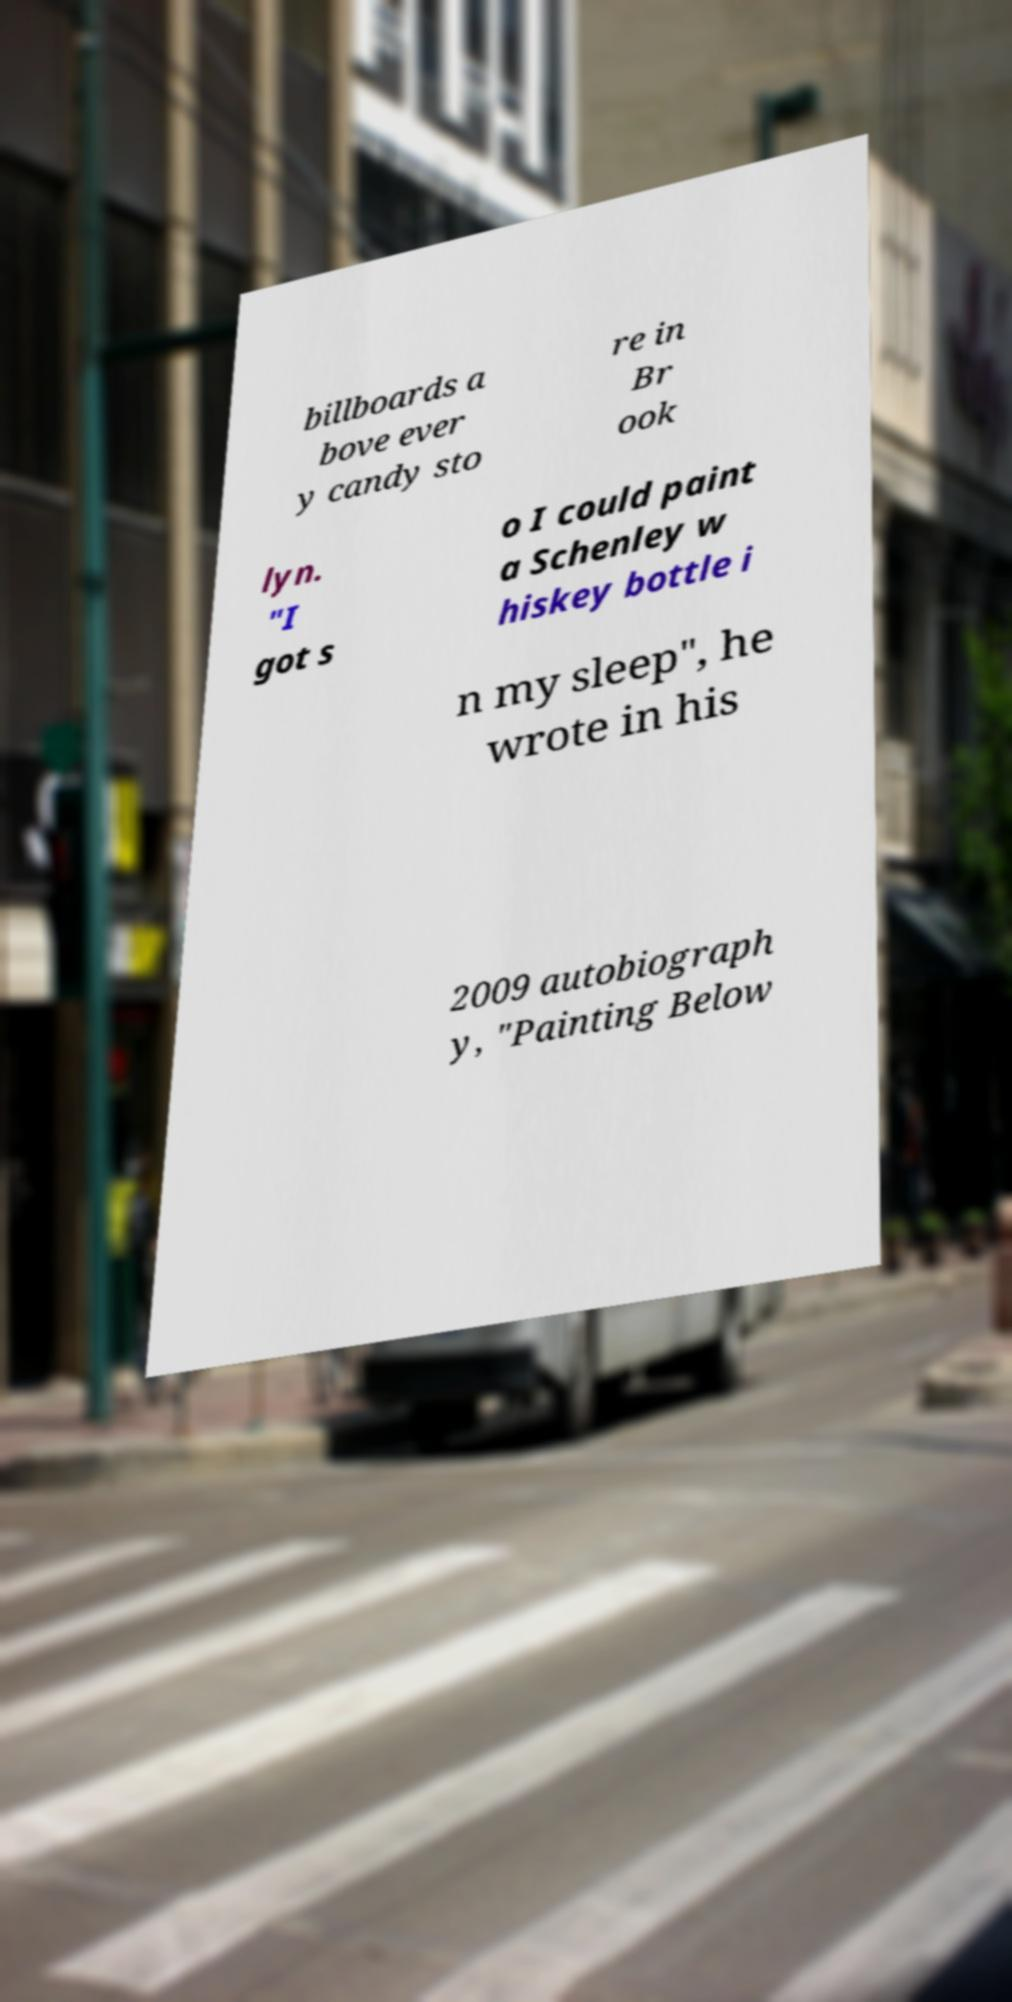Can you read and provide the text displayed in the image?This photo seems to have some interesting text. Can you extract and type it out for me? billboards a bove ever y candy sto re in Br ook lyn. "I got s o I could paint a Schenley w hiskey bottle i n my sleep", he wrote in his 2009 autobiograph y, "Painting Below 